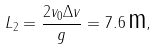<formula> <loc_0><loc_0><loc_500><loc_500>L _ { 2 } = \frac { 2 v _ { 0 } \Delta v } { g } = 7 . 6 \, { \mbox m } ,</formula> 